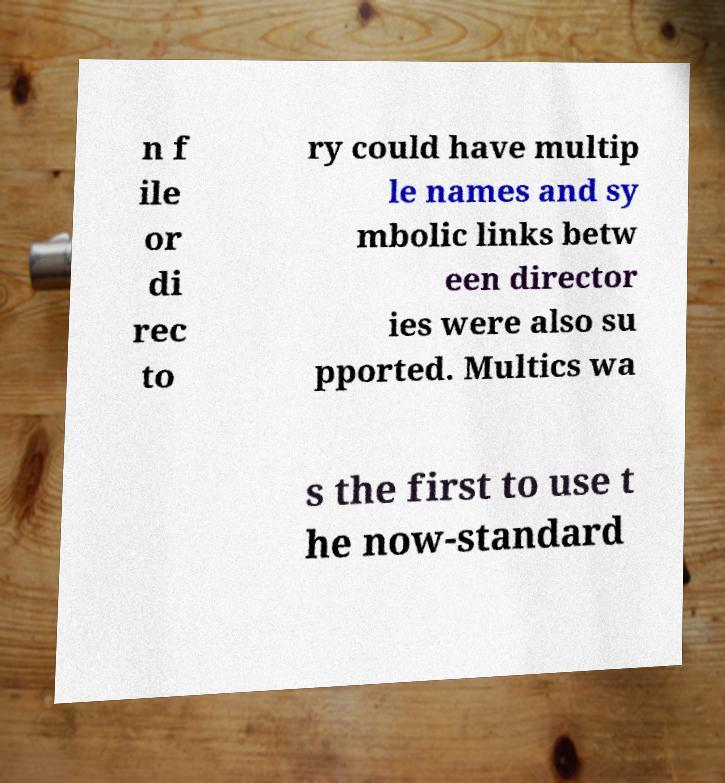Please identify and transcribe the text found in this image. n f ile or di rec to ry could have multip le names and sy mbolic links betw een director ies were also su pported. Multics wa s the first to use t he now-standard 